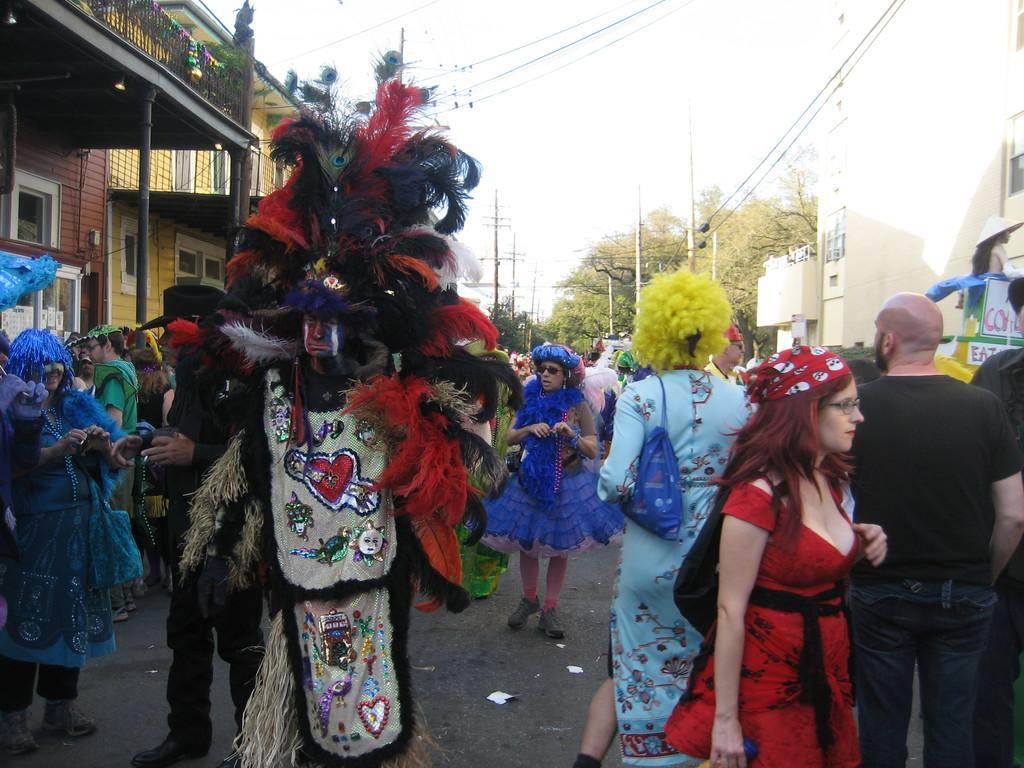Describe this image in one or two sentences. In this image there is crowd, there are few people wearing different colors of dresses, in the foreground there is a person wearing a costume hat, either side of the image there are buildings, in the middle there is the sky, power line cables, poles, trees visible. 